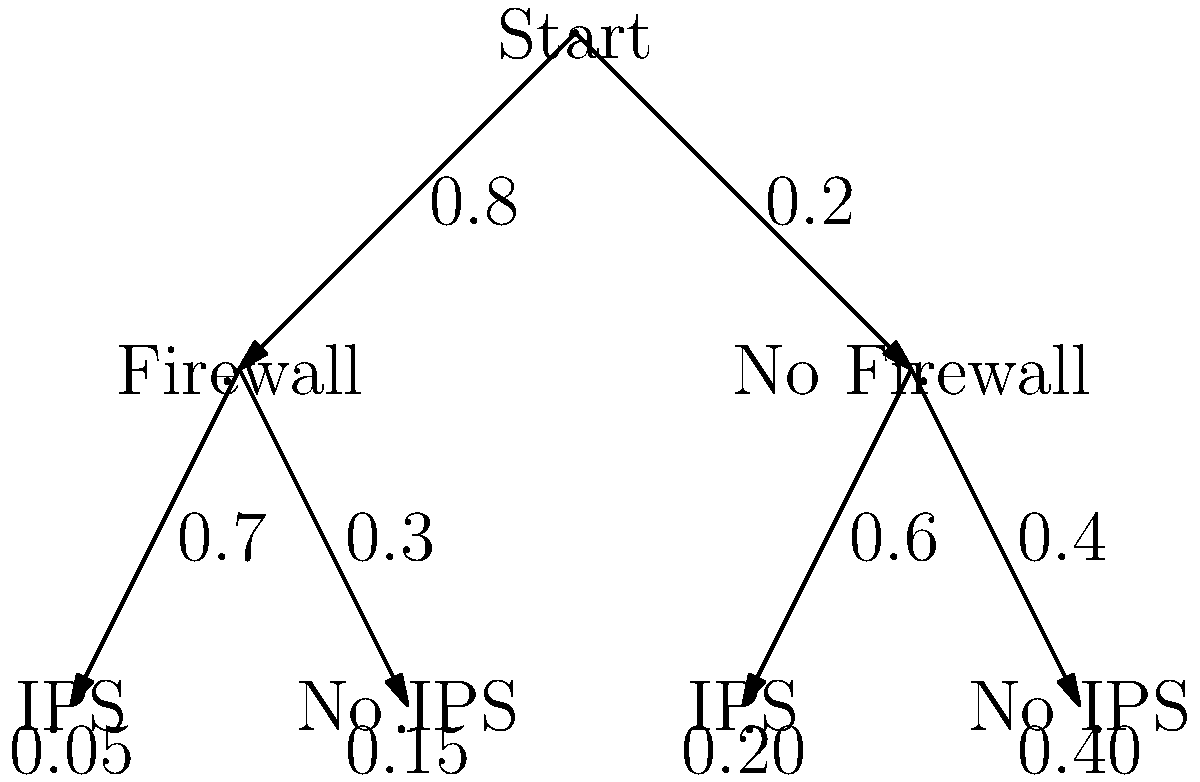A bank's IT infrastructure is being evaluated for potential cyberattack risks. The decision tree diagram above shows the probabilities of different security configurations and their associated success rates for cyberattacks. What is the overall probability of a successful cyberattack on the bank's system? To calculate the overall probability of a successful cyberattack, we need to sum the probabilities of all possible paths leading to a successful attack:

1. Path 1 (Firewall + IPS):
   $P(\text{Firewall}) \times P(\text{IPS}|\text{Firewall}) \times P(\text{Success}|\text{Firewall, IPS})$
   $= 0.8 \times 0.7 \times 0.05 = 0.028$

2. Path 2 (Firewall + No IPS):
   $P(\text{Firewall}) \times P(\text{No IPS}|\text{Firewall}) \times P(\text{Success}|\text{Firewall, No IPS})$
   $= 0.8 \times 0.3 \times 0.15 = 0.036$

3. Path 3 (No Firewall + IPS):
   $P(\text{No Firewall}) \times P(\text{IPS}|\text{No Firewall}) \times P(\text{Success}|\text{No Firewall, IPS})$
   $= 0.2 \times 0.6 \times 0.20 = 0.024$

4. Path 4 (No Firewall + No IPS):
   $P(\text{No Firewall}) \times P(\text{No IPS}|\text{No Firewall}) \times P(\text{Success}|\text{No Firewall, No IPS})$
   $= 0.2 \times 0.4 \times 0.40 = 0.032$

The overall probability is the sum of these four paths:
$0.028 + 0.036 + 0.024 + 0.032 = 0.120$
Answer: $0.120$ or $12\%$ 